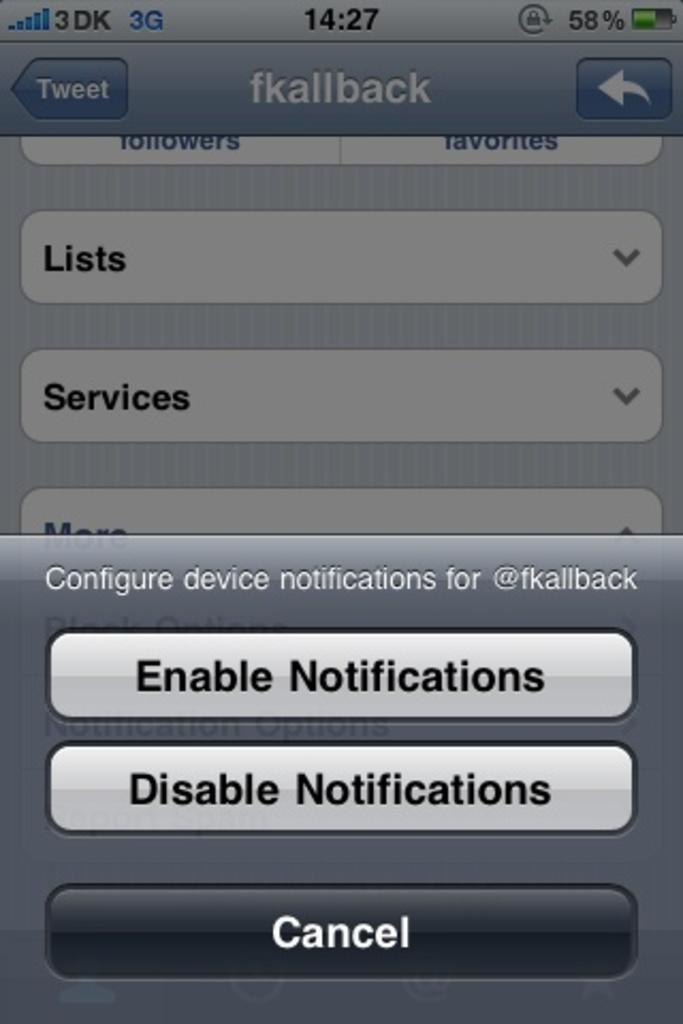<image>
Render a clear and concise summary of the photo. The home page of a mobile phone allowing the enabling or disabling of notifacations. 